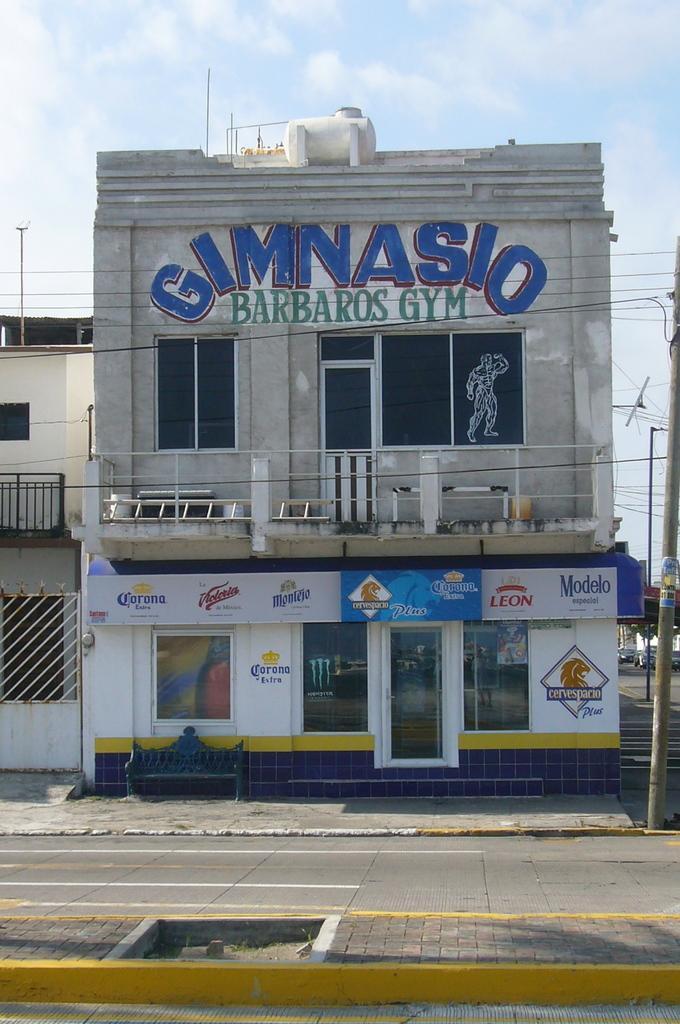Could you give a brief overview of what you see in this image? In the center of the image there is a building. At the bottom of the image there is a building. On the left side of the image there is a building. On the right side of the image we can see pole and road. In the background there are clouds and sky. 